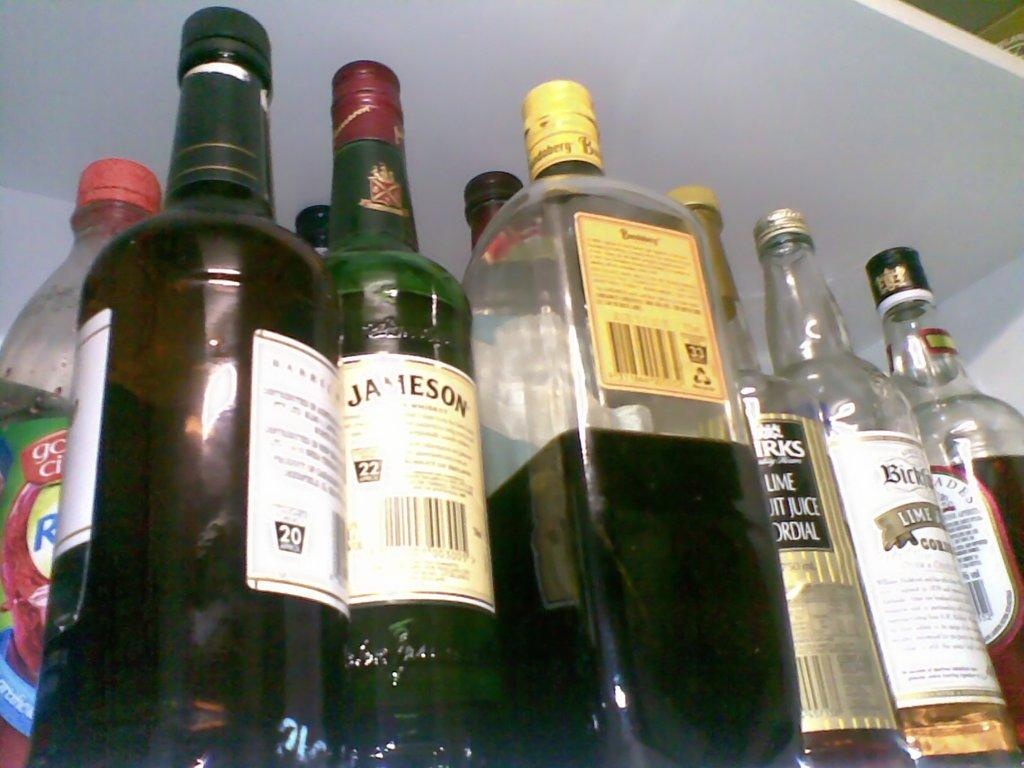<image>
Present a compact description of the photo's key features. Bottles of booze on a shelf, one bottle is Jameson. 